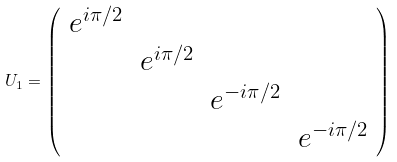Convert formula to latex. <formula><loc_0><loc_0><loc_500><loc_500>U _ { 1 } = \left ( \begin{array} { l l l l } e ^ { i \pi / 2 } & & & \\ & e ^ { i \pi / 2 } & & \\ & & e ^ { - i \pi / 2 } & \\ & & & e ^ { - i \pi / 2 } \end{array} \right )</formula> 